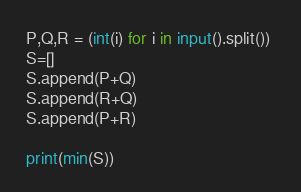Convert code to text. <code><loc_0><loc_0><loc_500><loc_500><_Python_>P,Q,R = (int(i) for i in input().split()) 
S=[]
S.append(P+Q)
S.append(R+Q)
S.append(P+R)

print(min(S))</code> 